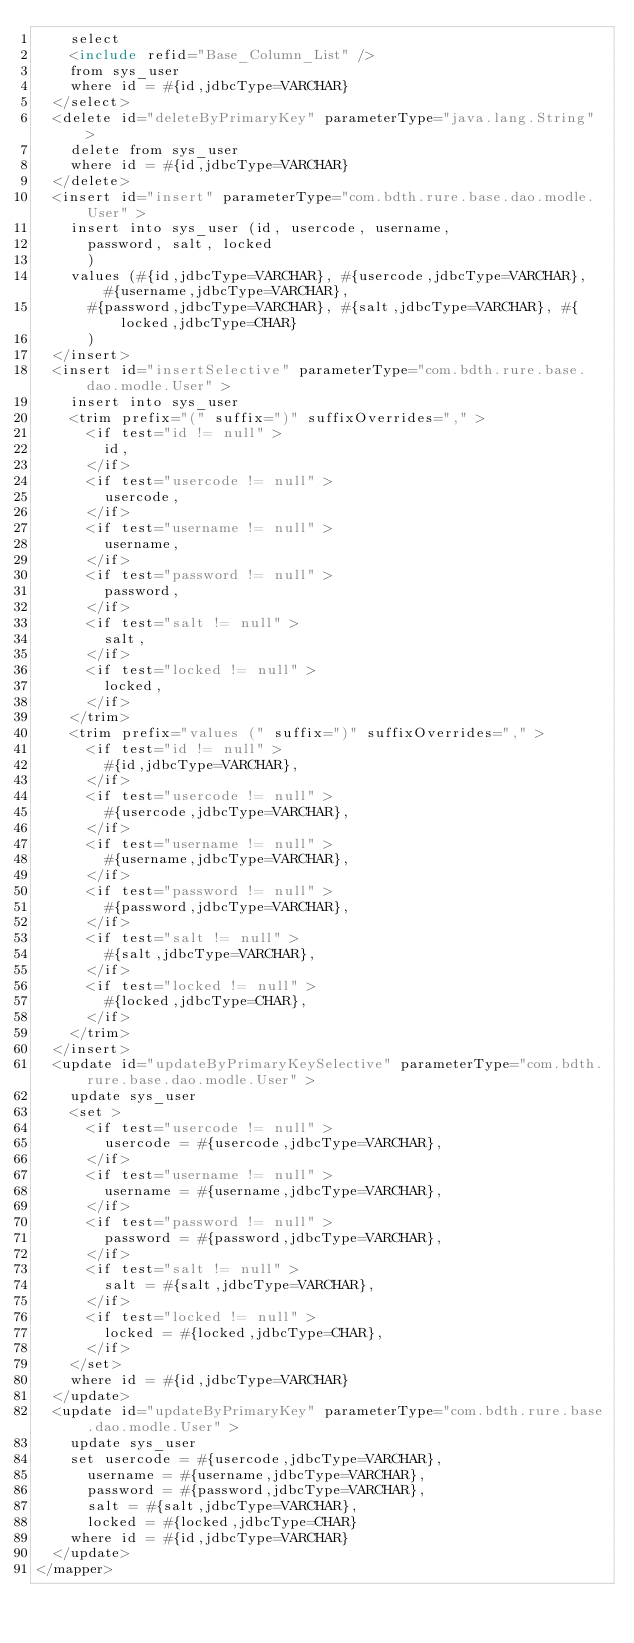Convert code to text. <code><loc_0><loc_0><loc_500><loc_500><_XML_>    select 
    <include refid="Base_Column_List" />
    from sys_user
    where id = #{id,jdbcType=VARCHAR}
  </select>
  <delete id="deleteByPrimaryKey" parameterType="java.lang.String" >
    delete from sys_user
    where id = #{id,jdbcType=VARCHAR}
  </delete>
  <insert id="insert" parameterType="com.bdth.rure.base.dao.modle.User" >
    insert into sys_user (id, usercode, username, 
      password, salt, locked
      )
    values (#{id,jdbcType=VARCHAR}, #{usercode,jdbcType=VARCHAR}, #{username,jdbcType=VARCHAR}, 
      #{password,jdbcType=VARCHAR}, #{salt,jdbcType=VARCHAR}, #{locked,jdbcType=CHAR}
      )
  </insert>
  <insert id="insertSelective" parameterType="com.bdth.rure.base.dao.modle.User" >
    insert into sys_user
    <trim prefix="(" suffix=")" suffixOverrides="," >
      <if test="id != null" >
        id,
      </if>
      <if test="usercode != null" >
        usercode,
      </if>
      <if test="username != null" >
        username,
      </if>
      <if test="password != null" >
        password,
      </if>
      <if test="salt != null" >
        salt,
      </if>
      <if test="locked != null" >
        locked,
      </if>
    </trim>
    <trim prefix="values (" suffix=")" suffixOverrides="," >
      <if test="id != null" >
        #{id,jdbcType=VARCHAR},
      </if>
      <if test="usercode != null" >
        #{usercode,jdbcType=VARCHAR},
      </if>
      <if test="username != null" >
        #{username,jdbcType=VARCHAR},
      </if>
      <if test="password != null" >
        #{password,jdbcType=VARCHAR},
      </if>
      <if test="salt != null" >
        #{salt,jdbcType=VARCHAR},
      </if>
      <if test="locked != null" >
        #{locked,jdbcType=CHAR},
      </if>
    </trim>
  </insert>
  <update id="updateByPrimaryKeySelective" parameterType="com.bdth.rure.base.dao.modle.User" >
    update sys_user
    <set >
      <if test="usercode != null" >
        usercode = #{usercode,jdbcType=VARCHAR},
      </if>
      <if test="username != null" >
        username = #{username,jdbcType=VARCHAR},
      </if>
      <if test="password != null" >
        password = #{password,jdbcType=VARCHAR},
      </if>
      <if test="salt != null" >
        salt = #{salt,jdbcType=VARCHAR},
      </if>
      <if test="locked != null" >
        locked = #{locked,jdbcType=CHAR},
      </if>
    </set>
    where id = #{id,jdbcType=VARCHAR}
  </update>
  <update id="updateByPrimaryKey" parameterType="com.bdth.rure.base.dao.modle.User" >
    update sys_user
    set usercode = #{usercode,jdbcType=VARCHAR},
      username = #{username,jdbcType=VARCHAR},
      password = #{password,jdbcType=VARCHAR},
      salt = #{salt,jdbcType=VARCHAR},
      locked = #{locked,jdbcType=CHAR}
    where id = #{id,jdbcType=VARCHAR}
  </update>
</mapper></code> 